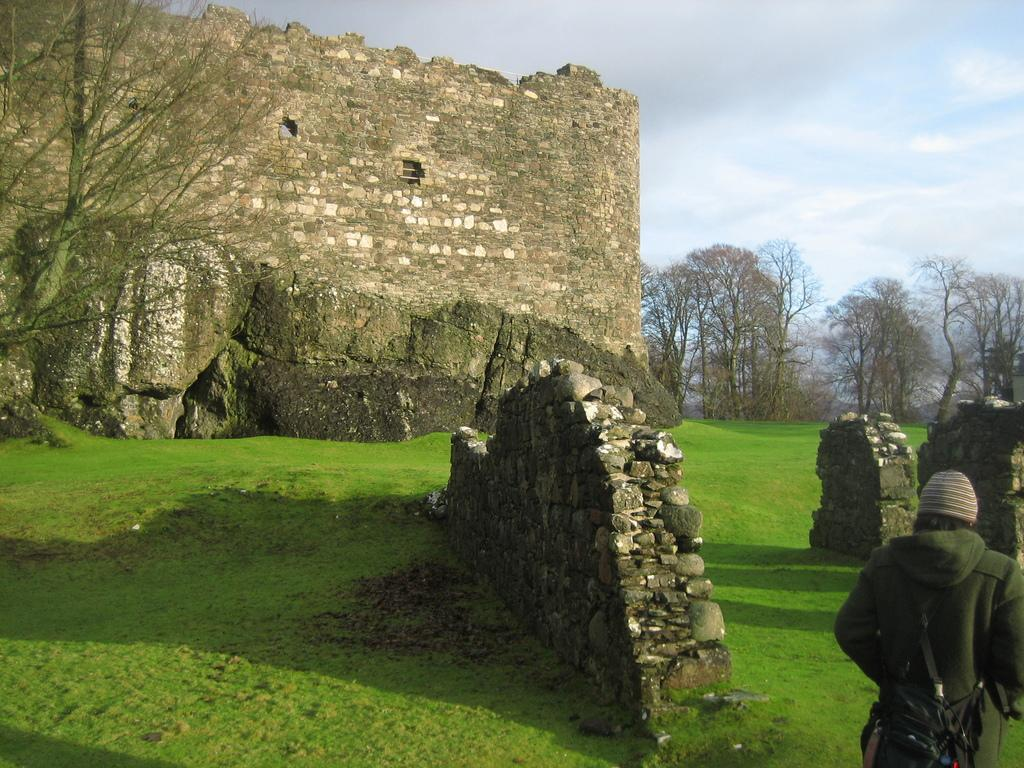What is the main structure in the image? There is a monument in the image. What is the person in the image doing? There is a person walking on the ground in the image. What type of vegetation can be seen in the image? There are trees in the image. What is visible in the background of the image? The sky is visible in the image, and clouds are present in the sky. What type of stick is the person holding in the image? There is no stick present in the image; the person is walking without holding anything. What act does the person regret performing in the image? There is no indication of regret or any specific act in the image; it simply shows a person walking near a monument. 